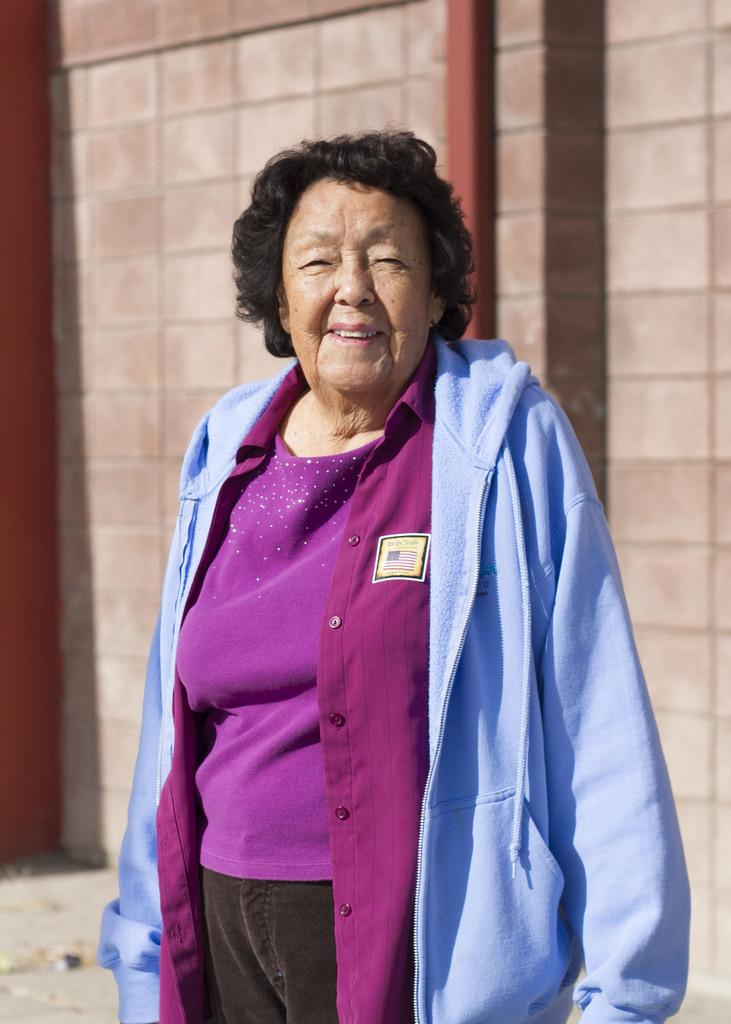Who is present in the image? There is a woman in the image. What is the woman doing in the image? The woman is standing in the image. What expression does the woman have? The woman is smiling in the image. What is the woman wearing in the image? The woman is wearing a blue color hoodie in the image. What can be seen in the background of the image? There is a wall in the background of the image. What type of poison can be seen in the woman's hand in the image? There is no poison present in the image; the woman is not holding anything in her hand. 